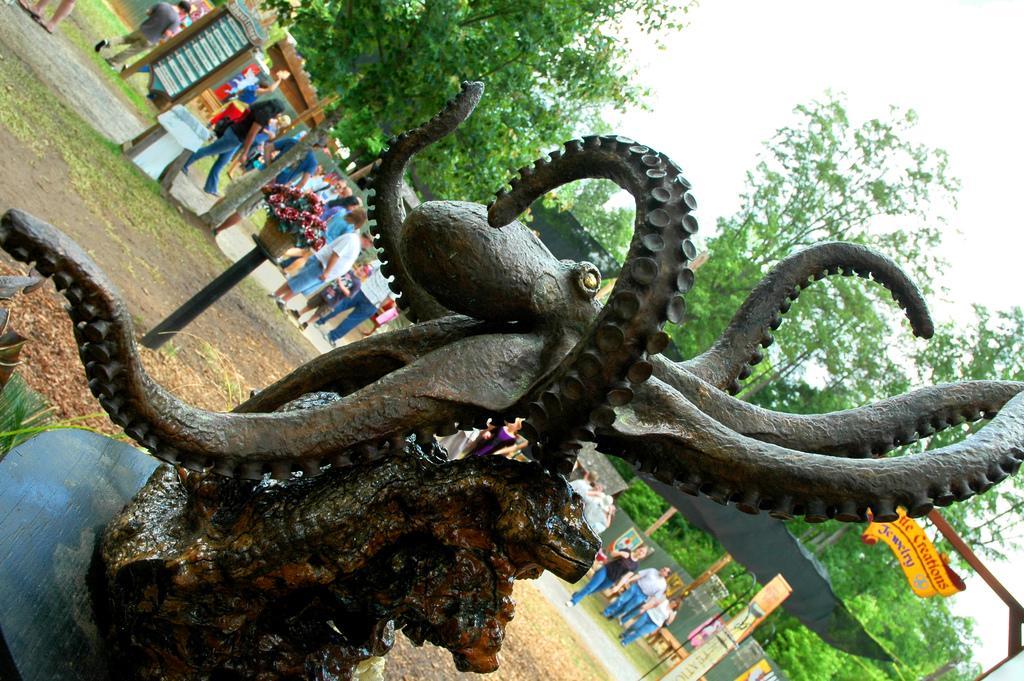In one or two sentences, can you explain what this image depicts? This image is taken outdoors. On the right side of the image there is a sky and there are many trees and there is a board with a text on it. In the background there is a fence and there are many boards with text on them. There are a few trees and a few people are walking on the ground and a few are standing on the ground. There is a plant in the pot and there is a ground with grass on it. In the middle of the image there is an artificial octopus. 